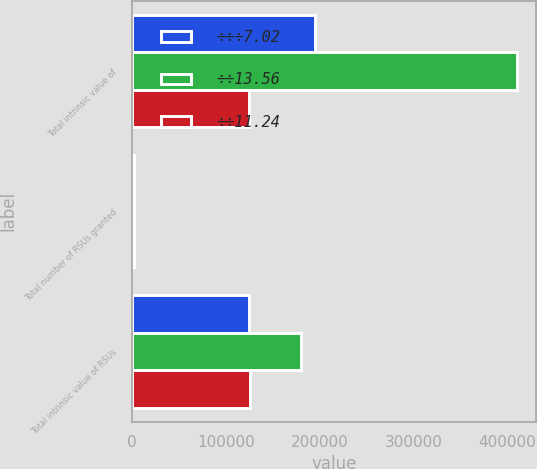Convert chart to OTSL. <chart><loc_0><loc_0><loc_500><loc_500><stacked_bar_chart><ecel><fcel>Total intrinsic value of<fcel>Total number of RSUs granted<fcel>Total intrinsic value of RSUs<nl><fcel>÷÷÷7.02<fcel>194545<fcel>2653<fcel>124193<nl><fcel>÷÷13.56<fcel>410152<fcel>2135<fcel>180563<nl><fcel>÷÷11.24<fcel>124854<fcel>2342<fcel>125514<nl></chart> 